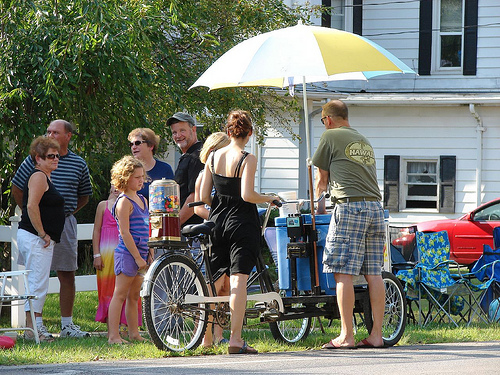<image>
Is the man under the umbrella? Yes. The man is positioned underneath the umbrella, with the umbrella above it in the vertical space. Is there a woman in front of the bike? No. The woman is not in front of the bike. The spatial positioning shows a different relationship between these objects. 